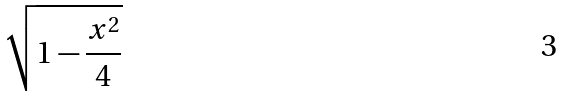Convert formula to latex. <formula><loc_0><loc_0><loc_500><loc_500>\sqrt { 1 - \frac { x ^ { 2 } } { 4 } }</formula> 